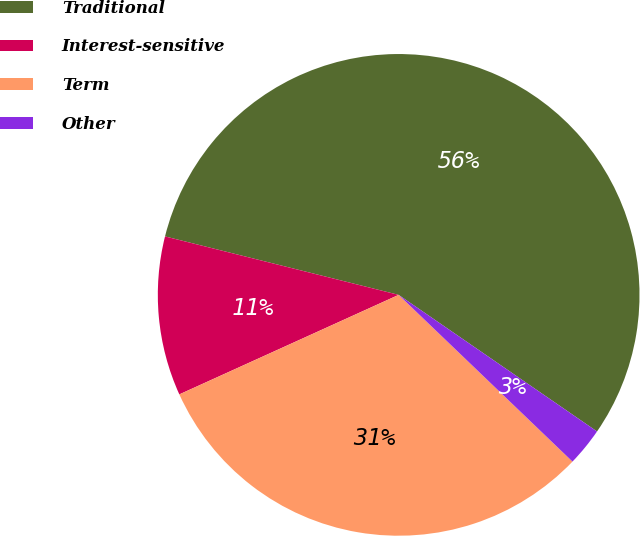Convert chart. <chart><loc_0><loc_0><loc_500><loc_500><pie_chart><fcel>Traditional<fcel>Interest-sensitive<fcel>Term<fcel>Other<nl><fcel>55.69%<fcel>10.68%<fcel>31.05%<fcel>2.57%<nl></chart> 